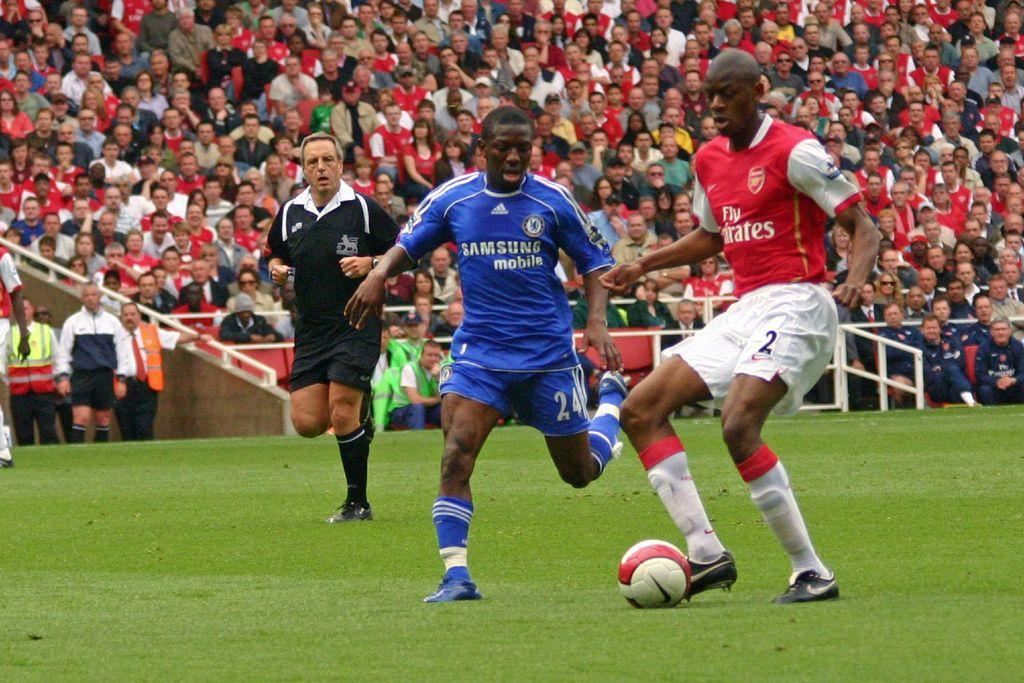<image>
Relay a brief, clear account of the picture shown. soccer players on a field with jerseys for Samsung and Fly Emirates 